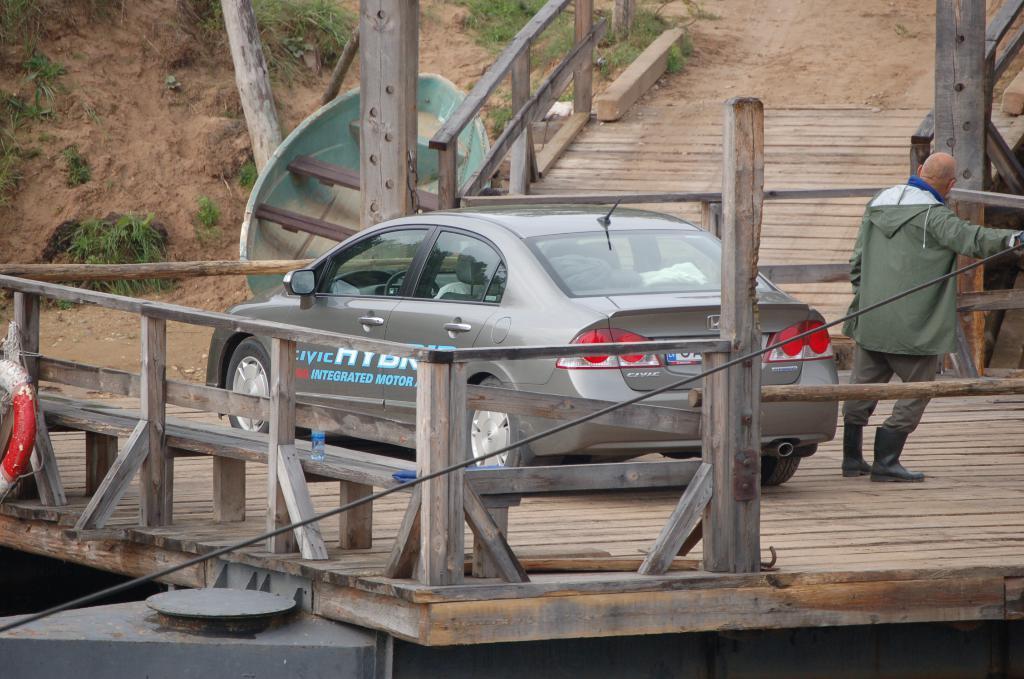Describe this image in one or two sentences. In this picture we can see a vehicle, person on a wooden platform, where we can see a fence, grass and some objects. 